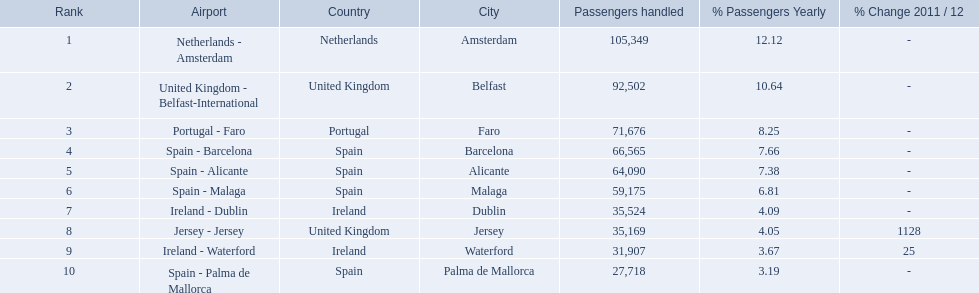What are the airports? Netherlands - Amsterdam, United Kingdom - Belfast-International, Portugal - Faro, Spain - Barcelona, Spain - Alicante, Spain - Malaga, Ireland - Dublin, Jersey - Jersey, Ireland - Waterford, Spain - Palma de Mallorca. Of these which has the least amount of passengers? Spain - Palma de Mallorca. 